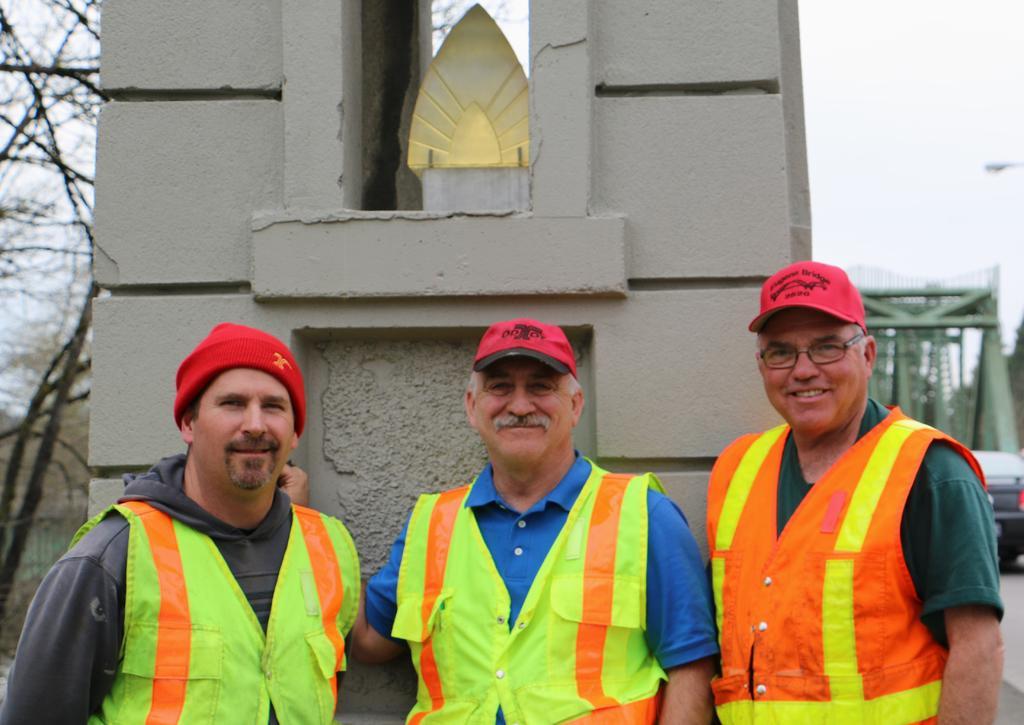Can you describe this image briefly? In this image, we can see three people are watching and smiling. They are wearing caps and jackets. Background we can see pillars, trees, vehicle, rods, road and sky. 